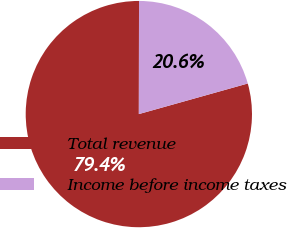Convert chart. <chart><loc_0><loc_0><loc_500><loc_500><pie_chart><fcel>Total revenue<fcel>Income before income taxes<nl><fcel>79.38%<fcel>20.62%<nl></chart> 